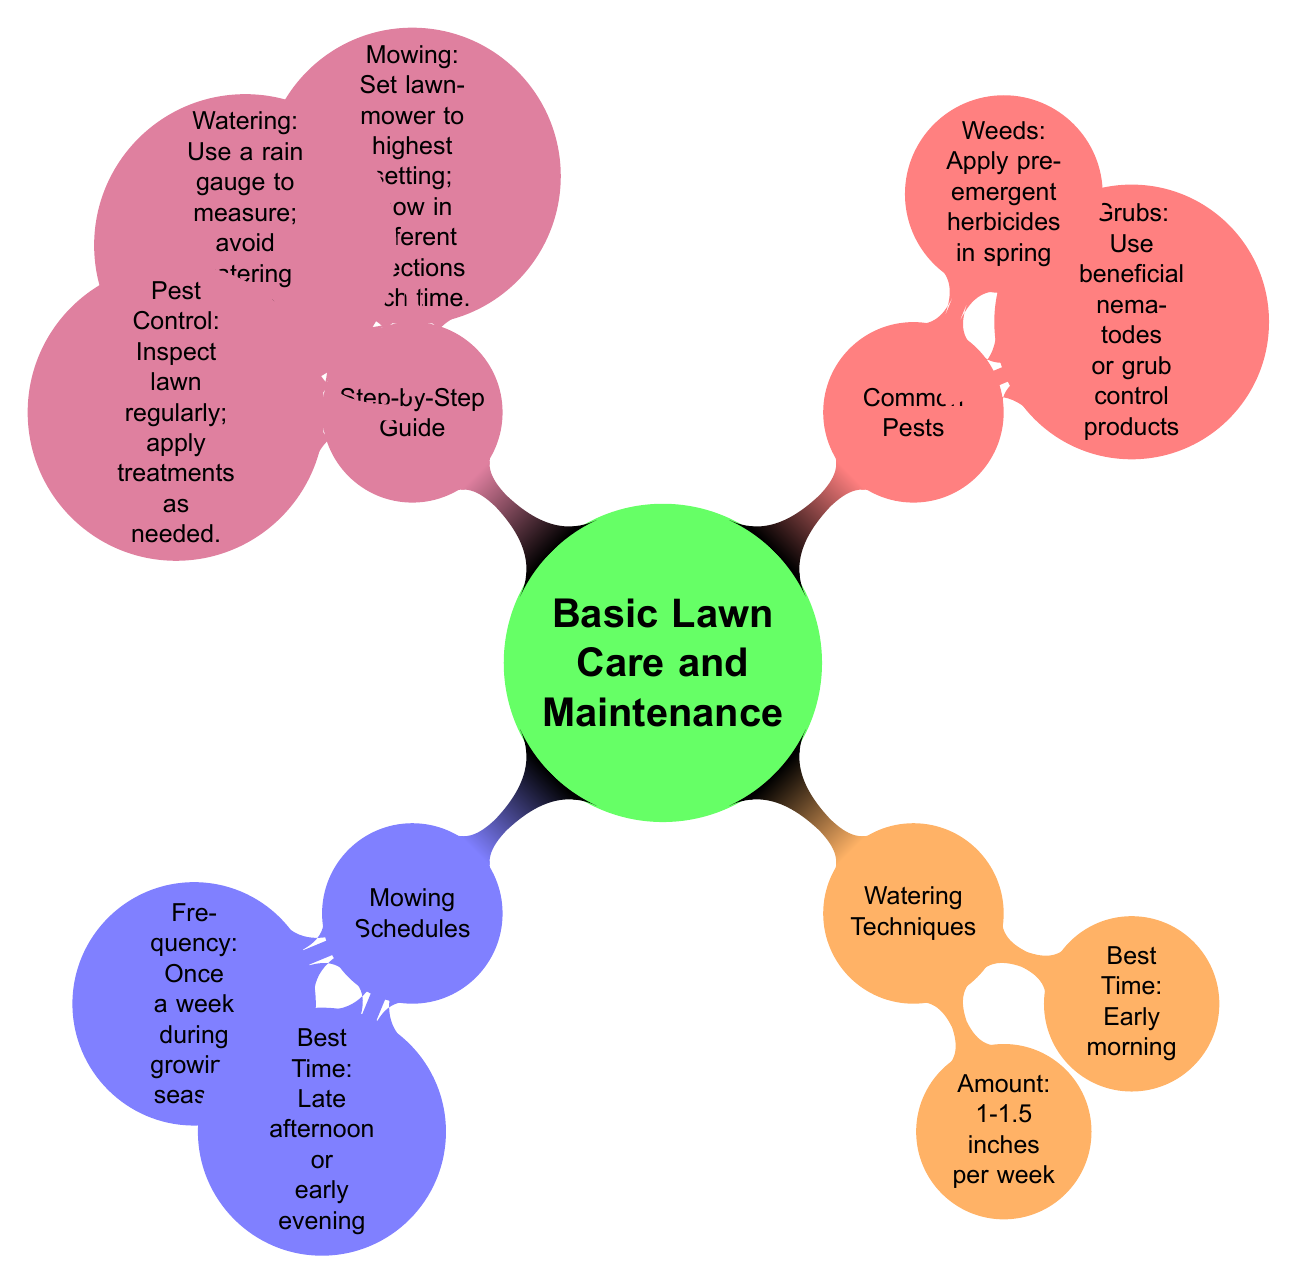What is the frequency of mowing during the growing season? The diagram specifies that the frequency of mowing is "Once a week during growing season."
Answer: Once a week What is the best time for watering? According to the diagram, the best time for watering is "Early morning."
Answer: Early morning How many main sections are in the basic lawn care diagram? The diagram shows four main sections: Mowing Schedules, Watering Techniques, Common Pests, and Step-by-Step Guide.
Answer: Four What is the recommended amount of water per week? The diagram indicates that the recommended amount of water is "1-1.5 inches per week."
Answer: 1-1.5 inches What should be done to control grubs? The diagram suggests to "Use beneficial nematodes or grub control products" for controlling grubs.
Answer: Use beneficial nematodes What is the recommended mowing setting? The diagram advises to "Set lawnmower to highest setting."
Answer: Highest setting What do you apply for weed control in spring? The diagram mentions to "Apply pre-emergent herbicides in spring" for weed control.
Answer: Apply pre-emergent herbicides When is the best time to mow? The diagram states that the best time to mow is "Late afternoon or early evening."
Answer: Late afternoon or early evening How should watering be measured? According to the diagram, you should "Use a rain gauge to measure" watering.
Answer: Use a rain gauge What is a key step in pest control? The diagram highlights "Inspect lawn regularly" as a key step in pest control.
Answer: Inspect lawn regularly 